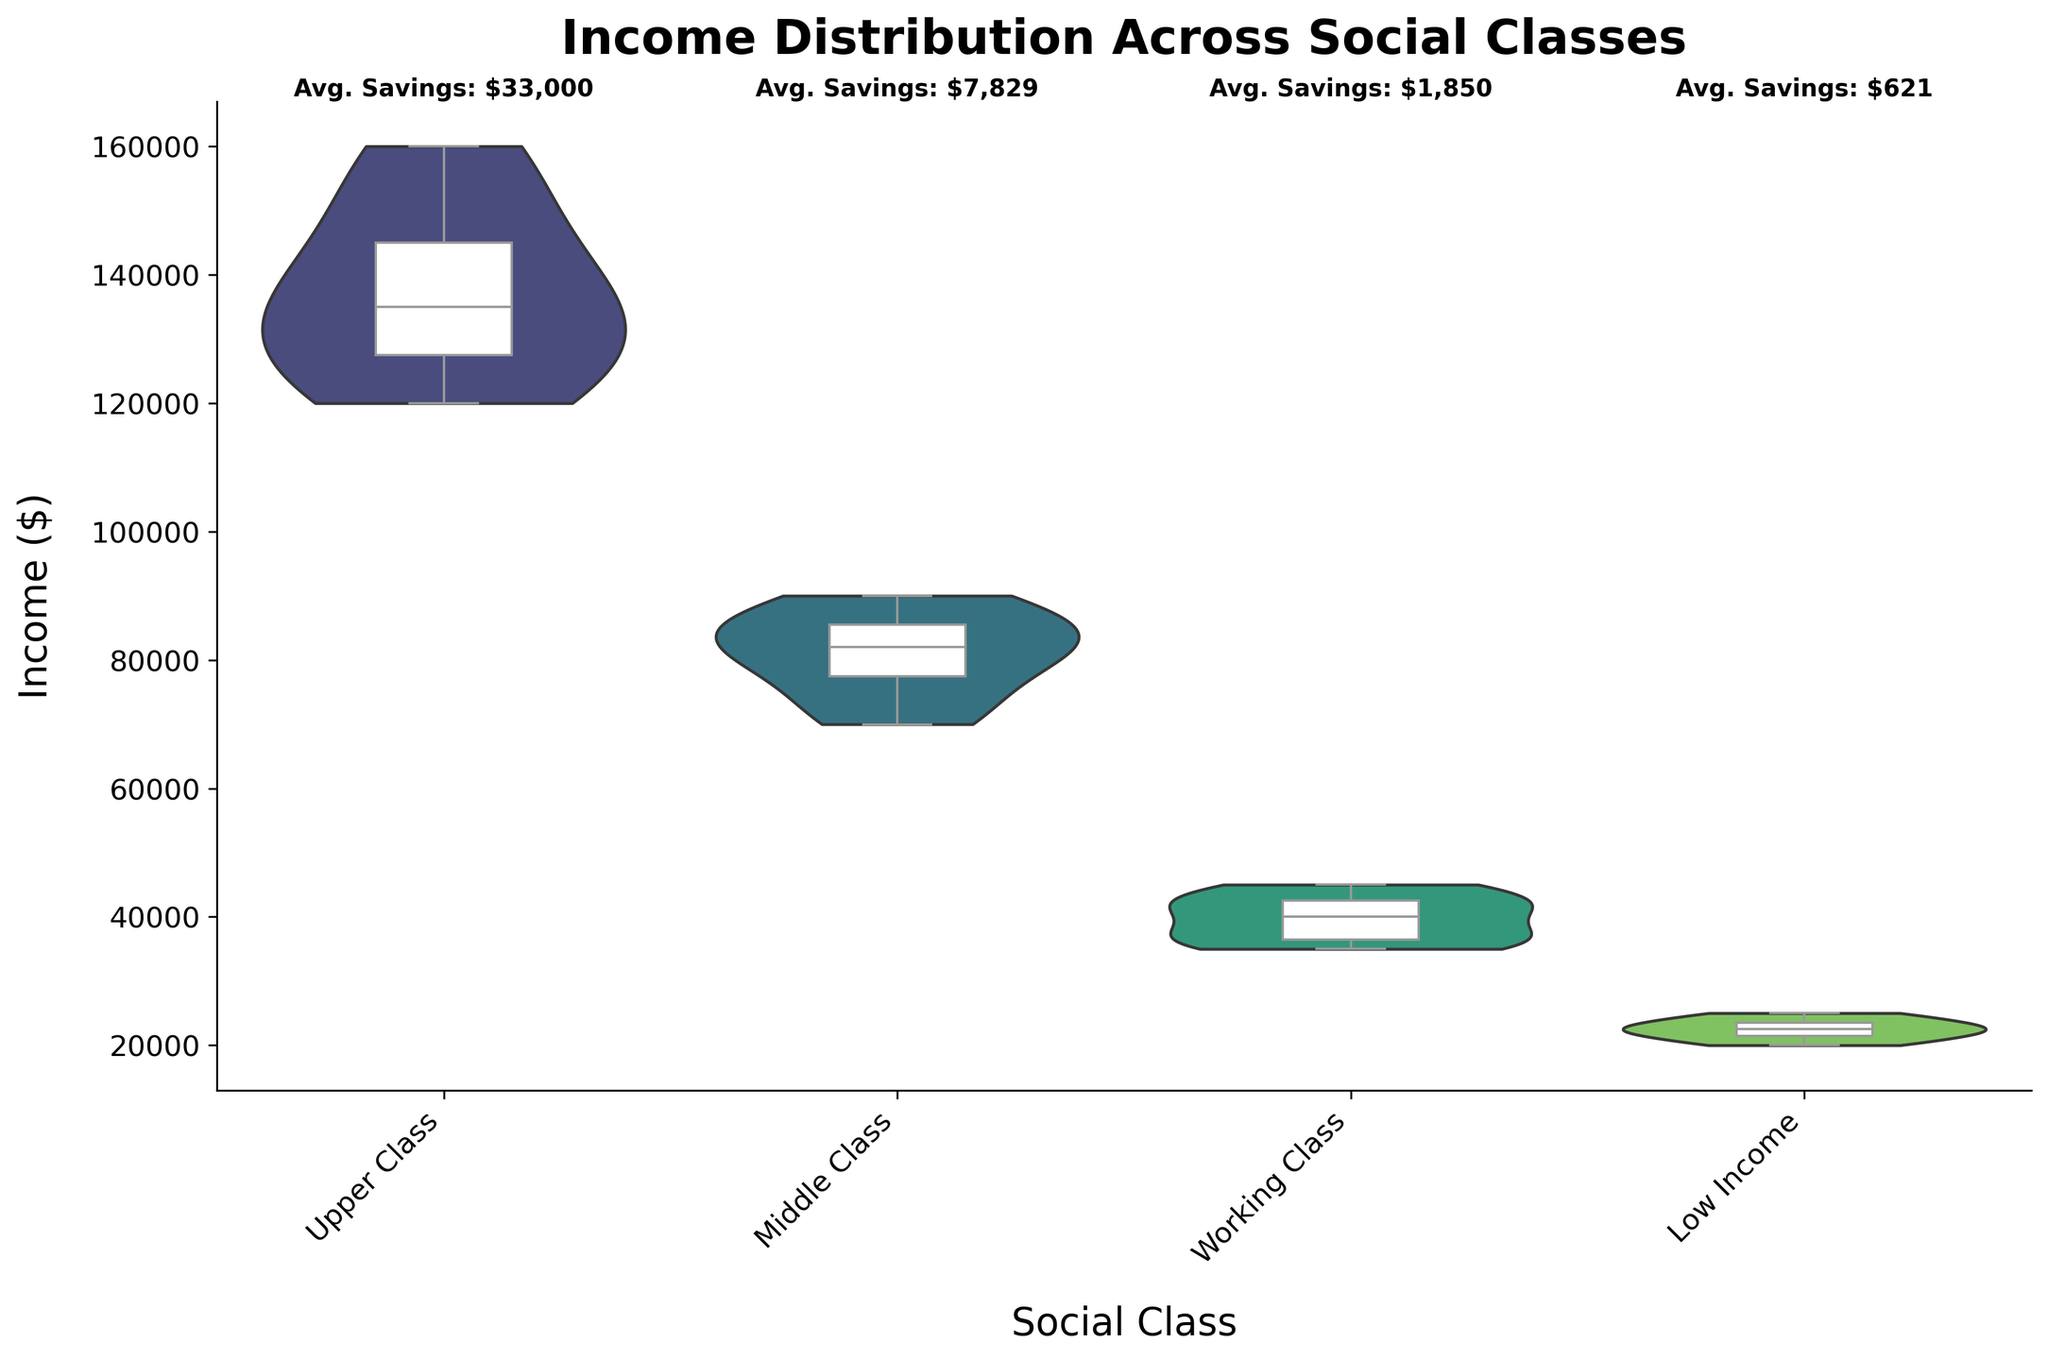What is the title of the figure? The title of the figure is displayed at the top, indicating the subject of the visual data. The title reads "Income Distribution Across Social Classes".
Answer: Income Distribution Across Social Classes What does the y-axis represent in this figure? The label on the y-axis indicates what the vertical axis represents. It is labeled as "Income ($)", which signifies that this axis shows the income values in dollars.
Answer: Income ($) Which social class has the highest average savings? The figure has annotations displaying the average savings for each social class at the top edge. The "Upper Class" shows the highest average savings of $33,833, which is greater than the averages for the other classes.
Answer: Upper Class How does the income distribution of the Middle Class compare to the Working Class? By comparing the violin plots representing income distribution, the Middle Class shows a higher and broader spread of income compared to the Working Class, which displays a lower and narrower distribution.
Answer: Middle Class has higher and broader spread Between which two social classes is the difference in income distribution most significant? To determine the most significant difference, one should compare the violin plots' spread and central tendencies. The most significant difference is between the "Upper Class" and "Low Income" classes. The Upper Class has a much higher and wider income distribution compared to the narrow and lower distribution of the Low Income class.
Answer: Upper Class and Low Income What is the median income for the Working Class? The median income can be inferred from the box plot in the center of the violin plot for the Working Class. The line inside the box represents the median, which appears to be around $40,000.
Answer: $40,000 Which social class shows the widest range of income distribution? By examining the span of the violin plots, the "Upper Class" shows the widest range of income distribution as its plot extends further compared to other classes.
Answer: Upper Class What is the average savings for the Low Income class? The average savings for each class is annotated at the top of the figure. For the Low Income class, the annotation shows the average savings as $621.43.
Answer: $621.43 What does the white box inside each violin plot represent? The white box inside each violin plot is a box plot that provides a summary of the income distribution, including the median, interquartile range (IQR), and potential outliers.
Answer: Summary of income distribution 